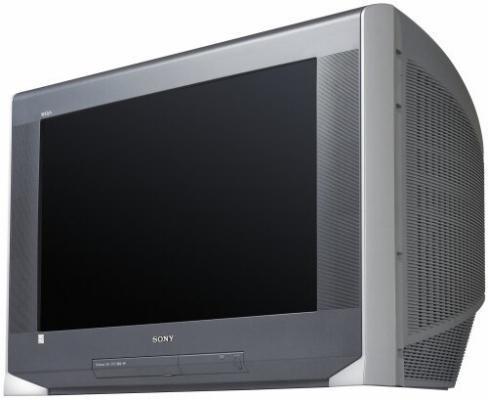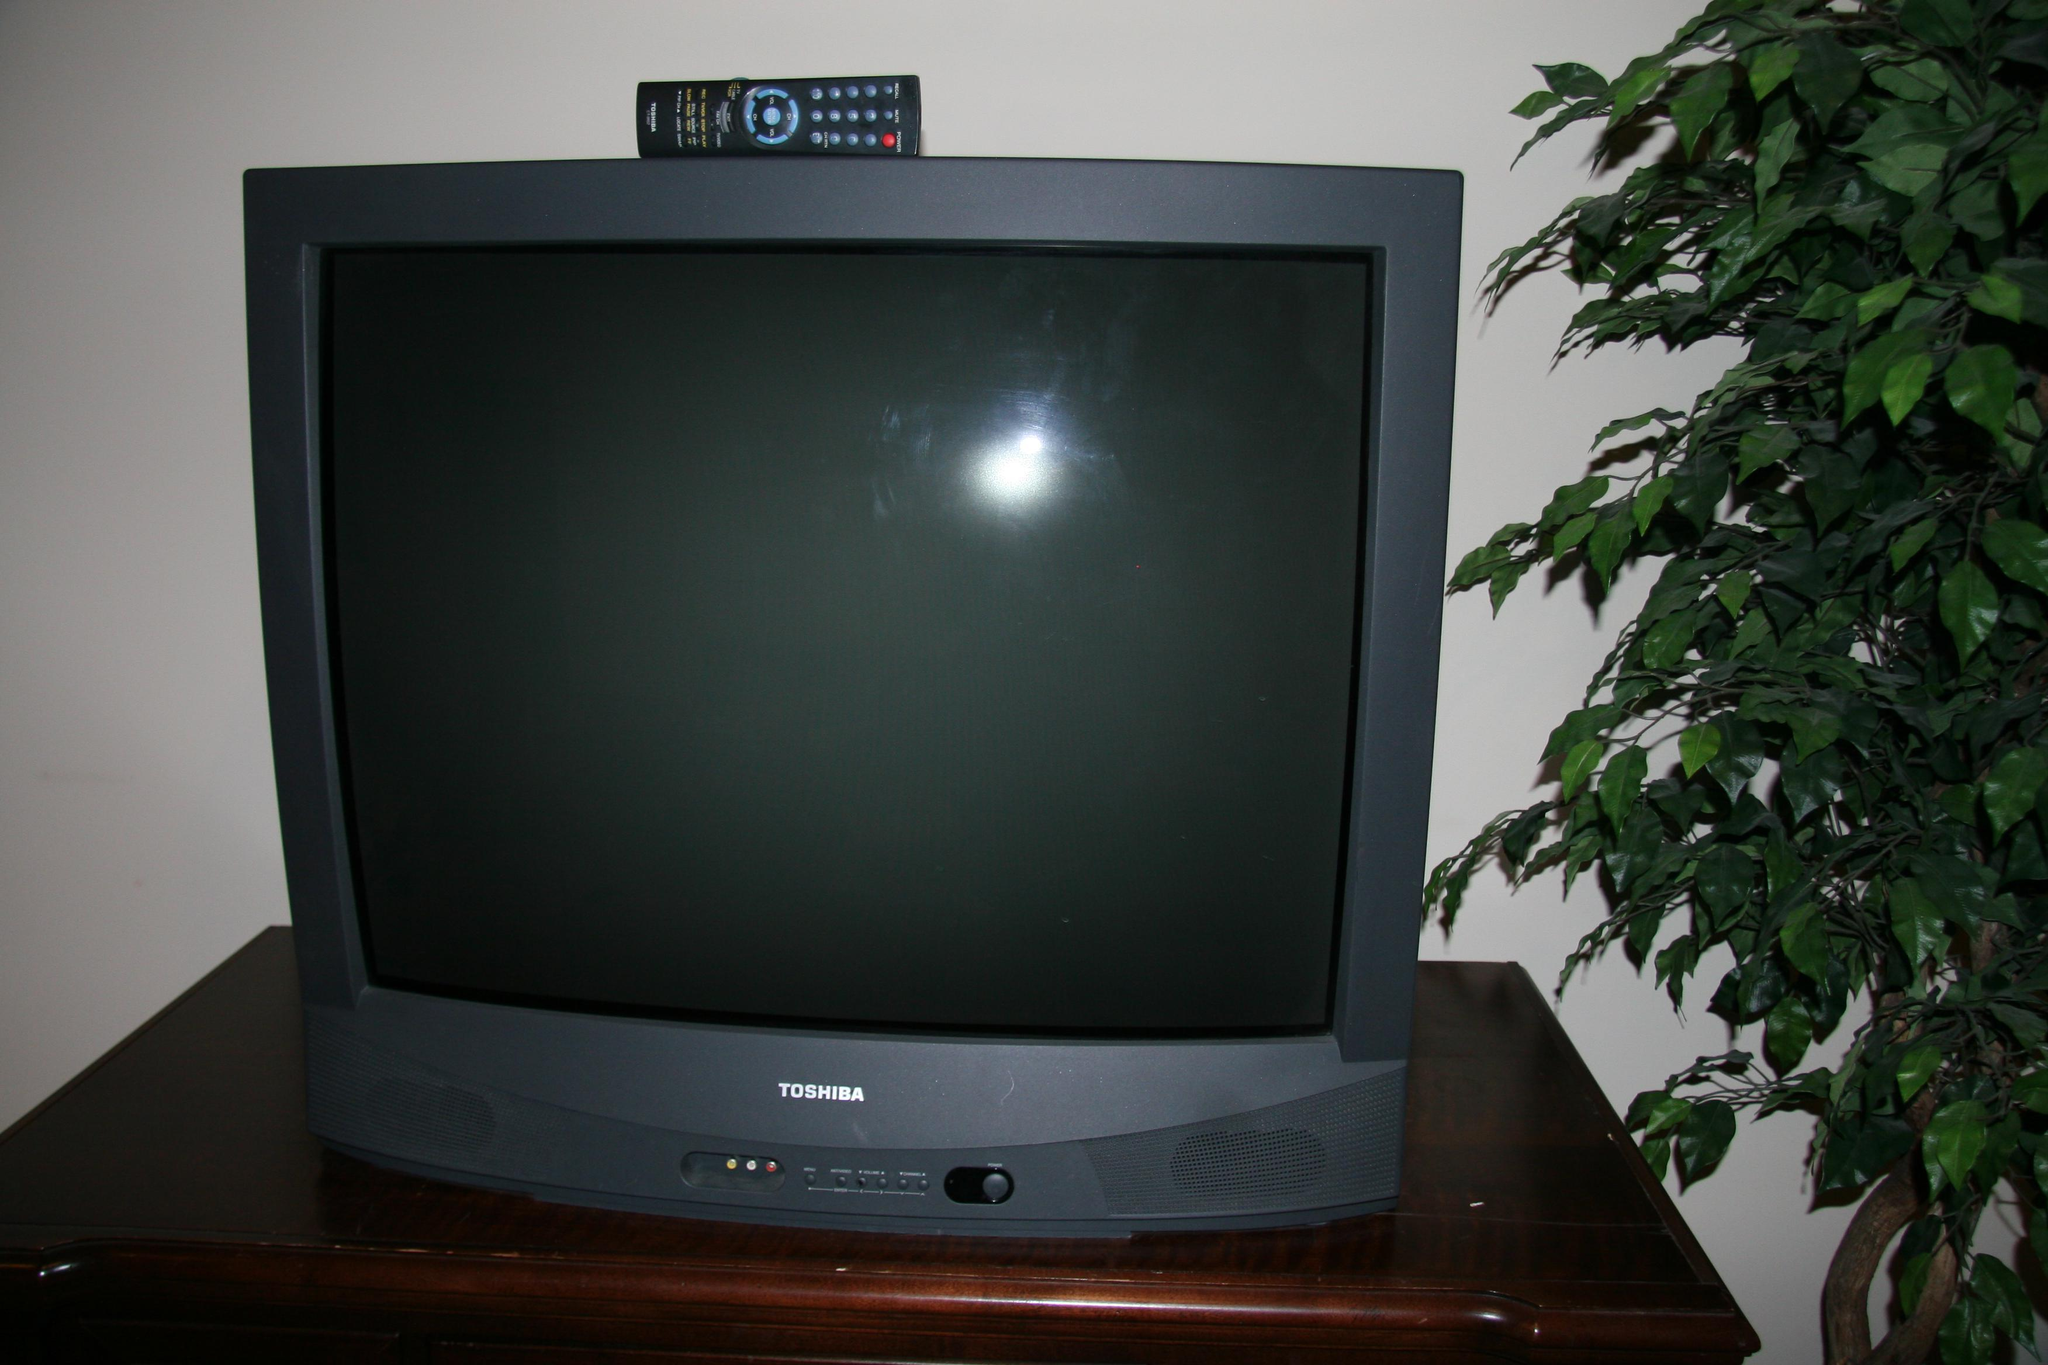The first image is the image on the left, the second image is the image on the right. Examine the images to the left and right. Is the description "Two televisions have the same boxy shape and screens, but one has visible tuning controls at the bottom while the other has a small panel door in the same place." accurate? Answer yes or no. Yes. The first image is the image on the left, the second image is the image on the right. Considering the images on both sides, is "One image shows an old-fashioned TV set with two large knobs arranged vertically alongside the screen." valid? Answer yes or no. No. 